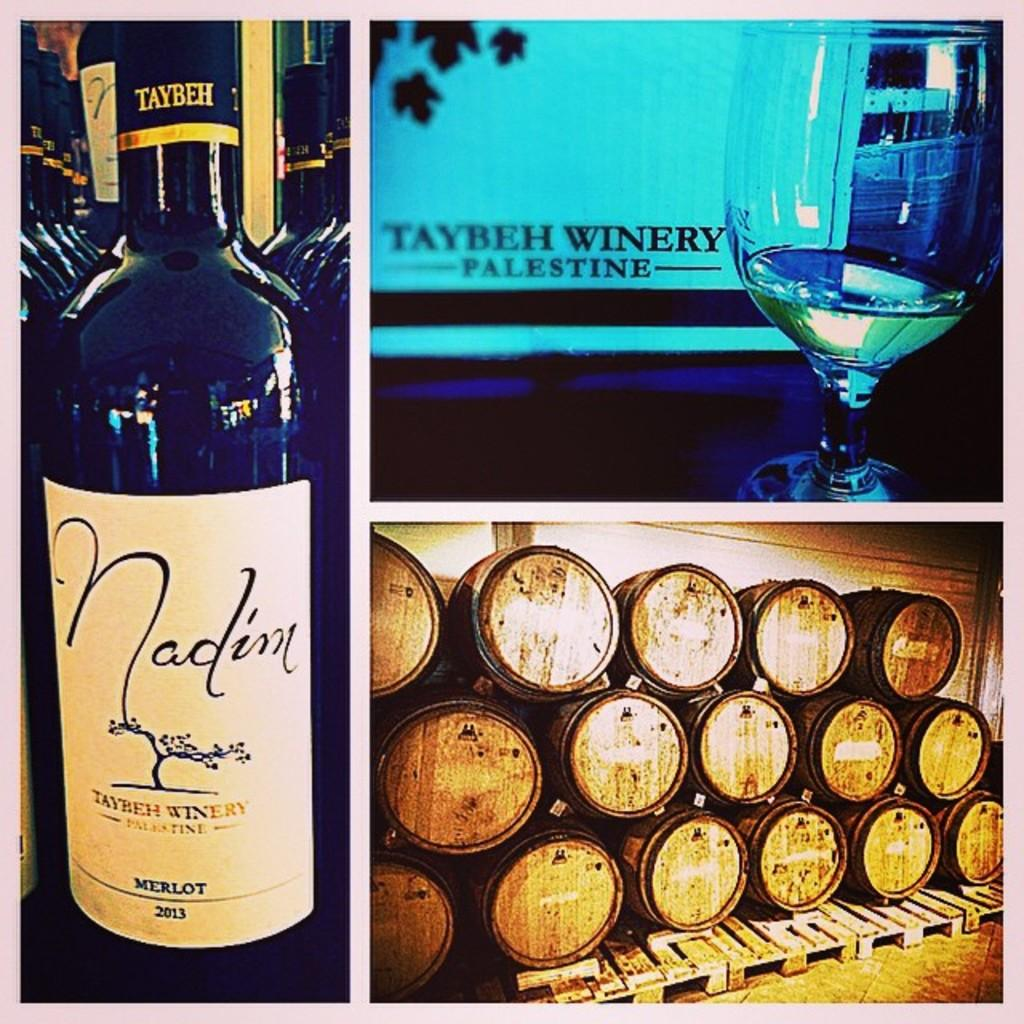Provide a one-sentence caption for the provided image. A bottle of merlot is shown with a glass of wine and a pile of barrels. 